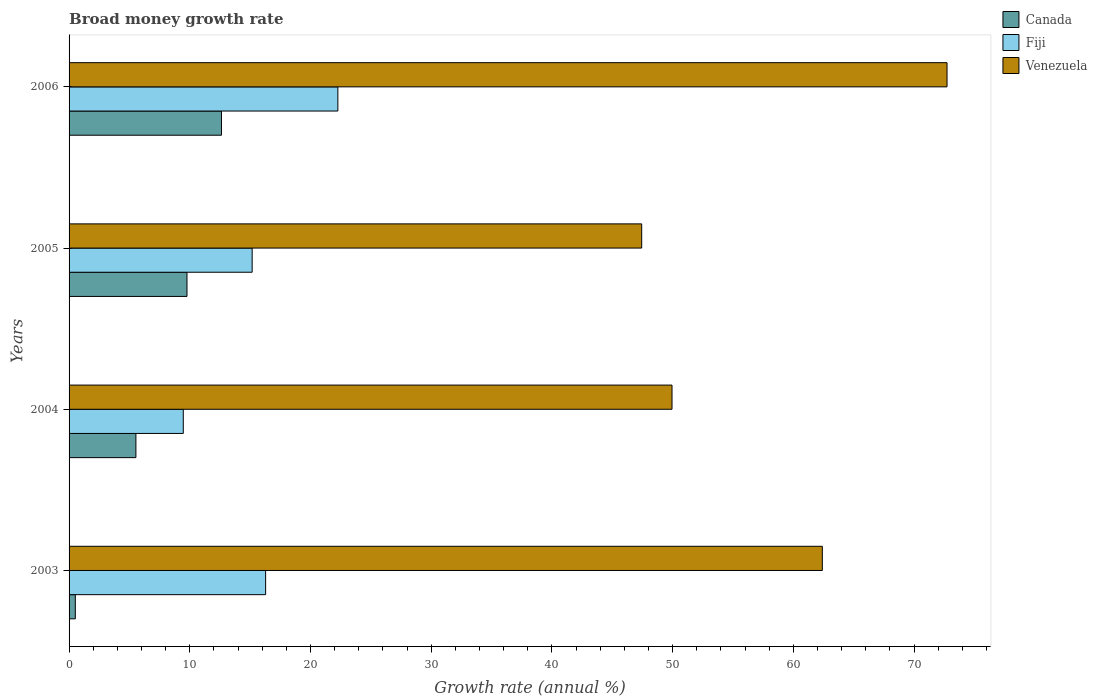How many different coloured bars are there?
Provide a short and direct response. 3. Are the number of bars per tick equal to the number of legend labels?
Your answer should be very brief. Yes. Are the number of bars on each tick of the Y-axis equal?
Ensure brevity in your answer.  Yes. How many bars are there on the 2nd tick from the bottom?
Make the answer very short. 3. What is the label of the 2nd group of bars from the top?
Your answer should be very brief. 2005. In how many cases, is the number of bars for a given year not equal to the number of legend labels?
Your answer should be very brief. 0. What is the growth rate in Canada in 2006?
Make the answer very short. 12.63. Across all years, what is the maximum growth rate in Fiji?
Your answer should be very brief. 22.27. Across all years, what is the minimum growth rate in Venezuela?
Keep it short and to the point. 47.44. In which year was the growth rate in Venezuela minimum?
Your response must be concise. 2005. What is the total growth rate in Fiji in the graph?
Your answer should be compact. 63.18. What is the difference between the growth rate in Canada in 2003 and that in 2005?
Provide a succinct answer. -9.25. What is the difference between the growth rate in Venezuela in 2004 and the growth rate in Fiji in 2003?
Your answer should be compact. 33.67. What is the average growth rate in Fiji per year?
Your answer should be compact. 15.8. In the year 2003, what is the difference between the growth rate in Venezuela and growth rate in Fiji?
Offer a terse response. 46.12. What is the ratio of the growth rate in Fiji in 2003 to that in 2005?
Keep it short and to the point. 1.07. Is the difference between the growth rate in Venezuela in 2003 and 2006 greater than the difference between the growth rate in Fiji in 2003 and 2006?
Provide a succinct answer. No. What is the difference between the highest and the second highest growth rate in Fiji?
Ensure brevity in your answer.  5.98. What is the difference between the highest and the lowest growth rate in Canada?
Your response must be concise. 12.11. In how many years, is the growth rate in Venezuela greater than the average growth rate in Venezuela taken over all years?
Your answer should be compact. 2. What does the 2nd bar from the top in 2003 represents?
Provide a short and direct response. Fiji. What does the 1st bar from the bottom in 2005 represents?
Offer a very short reply. Canada. Is it the case that in every year, the sum of the growth rate in Venezuela and growth rate in Fiji is greater than the growth rate in Canada?
Your answer should be compact. Yes. Are all the bars in the graph horizontal?
Ensure brevity in your answer.  Yes. Are the values on the major ticks of X-axis written in scientific E-notation?
Your answer should be compact. No. Does the graph contain grids?
Your response must be concise. No. How many legend labels are there?
Make the answer very short. 3. How are the legend labels stacked?
Keep it short and to the point. Vertical. What is the title of the graph?
Your response must be concise. Broad money growth rate. Does "Qatar" appear as one of the legend labels in the graph?
Keep it short and to the point. No. What is the label or title of the X-axis?
Give a very brief answer. Growth rate (annual %). What is the label or title of the Y-axis?
Offer a very short reply. Years. What is the Growth rate (annual %) of Canada in 2003?
Provide a succinct answer. 0.52. What is the Growth rate (annual %) of Fiji in 2003?
Your answer should be very brief. 16.28. What is the Growth rate (annual %) in Venezuela in 2003?
Offer a very short reply. 62.41. What is the Growth rate (annual %) in Canada in 2004?
Your response must be concise. 5.54. What is the Growth rate (annual %) of Fiji in 2004?
Provide a succinct answer. 9.46. What is the Growth rate (annual %) in Venezuela in 2004?
Your response must be concise. 49.95. What is the Growth rate (annual %) in Canada in 2005?
Provide a succinct answer. 9.77. What is the Growth rate (annual %) of Fiji in 2005?
Your answer should be very brief. 15.17. What is the Growth rate (annual %) in Venezuela in 2005?
Your answer should be compact. 47.44. What is the Growth rate (annual %) in Canada in 2006?
Provide a succinct answer. 12.63. What is the Growth rate (annual %) of Fiji in 2006?
Offer a very short reply. 22.27. What is the Growth rate (annual %) in Venezuela in 2006?
Your response must be concise. 72.74. Across all years, what is the maximum Growth rate (annual %) in Canada?
Your answer should be compact. 12.63. Across all years, what is the maximum Growth rate (annual %) in Fiji?
Offer a very short reply. 22.27. Across all years, what is the maximum Growth rate (annual %) in Venezuela?
Keep it short and to the point. 72.74. Across all years, what is the minimum Growth rate (annual %) in Canada?
Offer a very short reply. 0.52. Across all years, what is the minimum Growth rate (annual %) of Fiji?
Your response must be concise. 9.46. Across all years, what is the minimum Growth rate (annual %) in Venezuela?
Keep it short and to the point. 47.44. What is the total Growth rate (annual %) in Canada in the graph?
Give a very brief answer. 28.45. What is the total Growth rate (annual %) in Fiji in the graph?
Your answer should be compact. 63.18. What is the total Growth rate (annual %) of Venezuela in the graph?
Your response must be concise. 232.53. What is the difference between the Growth rate (annual %) of Canada in 2003 and that in 2004?
Offer a terse response. -5.02. What is the difference between the Growth rate (annual %) in Fiji in 2003 and that in 2004?
Make the answer very short. 6.82. What is the difference between the Growth rate (annual %) of Venezuela in 2003 and that in 2004?
Ensure brevity in your answer.  12.45. What is the difference between the Growth rate (annual %) in Canada in 2003 and that in 2005?
Offer a very short reply. -9.25. What is the difference between the Growth rate (annual %) of Fiji in 2003 and that in 2005?
Give a very brief answer. 1.12. What is the difference between the Growth rate (annual %) of Venezuela in 2003 and that in 2005?
Offer a very short reply. 14.97. What is the difference between the Growth rate (annual %) in Canada in 2003 and that in 2006?
Provide a succinct answer. -12.11. What is the difference between the Growth rate (annual %) in Fiji in 2003 and that in 2006?
Your answer should be compact. -5.98. What is the difference between the Growth rate (annual %) in Venezuela in 2003 and that in 2006?
Provide a succinct answer. -10.33. What is the difference between the Growth rate (annual %) in Canada in 2004 and that in 2005?
Provide a short and direct response. -4.23. What is the difference between the Growth rate (annual %) of Fiji in 2004 and that in 2005?
Keep it short and to the point. -5.71. What is the difference between the Growth rate (annual %) of Venezuela in 2004 and that in 2005?
Your answer should be very brief. 2.51. What is the difference between the Growth rate (annual %) in Canada in 2004 and that in 2006?
Your answer should be very brief. -7.09. What is the difference between the Growth rate (annual %) of Fiji in 2004 and that in 2006?
Ensure brevity in your answer.  -12.81. What is the difference between the Growth rate (annual %) in Venezuela in 2004 and that in 2006?
Make the answer very short. -22.78. What is the difference between the Growth rate (annual %) of Canada in 2005 and that in 2006?
Offer a terse response. -2.86. What is the difference between the Growth rate (annual %) of Venezuela in 2005 and that in 2006?
Offer a very short reply. -25.3. What is the difference between the Growth rate (annual %) in Canada in 2003 and the Growth rate (annual %) in Fiji in 2004?
Give a very brief answer. -8.94. What is the difference between the Growth rate (annual %) of Canada in 2003 and the Growth rate (annual %) of Venezuela in 2004?
Your answer should be compact. -49.43. What is the difference between the Growth rate (annual %) of Fiji in 2003 and the Growth rate (annual %) of Venezuela in 2004?
Ensure brevity in your answer.  -33.67. What is the difference between the Growth rate (annual %) in Canada in 2003 and the Growth rate (annual %) in Fiji in 2005?
Give a very brief answer. -14.65. What is the difference between the Growth rate (annual %) of Canada in 2003 and the Growth rate (annual %) of Venezuela in 2005?
Keep it short and to the point. -46.92. What is the difference between the Growth rate (annual %) in Fiji in 2003 and the Growth rate (annual %) in Venezuela in 2005?
Provide a succinct answer. -31.16. What is the difference between the Growth rate (annual %) in Canada in 2003 and the Growth rate (annual %) in Fiji in 2006?
Keep it short and to the point. -21.75. What is the difference between the Growth rate (annual %) of Canada in 2003 and the Growth rate (annual %) of Venezuela in 2006?
Your answer should be very brief. -72.22. What is the difference between the Growth rate (annual %) of Fiji in 2003 and the Growth rate (annual %) of Venezuela in 2006?
Offer a terse response. -56.45. What is the difference between the Growth rate (annual %) of Canada in 2004 and the Growth rate (annual %) of Fiji in 2005?
Give a very brief answer. -9.63. What is the difference between the Growth rate (annual %) in Canada in 2004 and the Growth rate (annual %) in Venezuela in 2005?
Offer a terse response. -41.9. What is the difference between the Growth rate (annual %) of Fiji in 2004 and the Growth rate (annual %) of Venezuela in 2005?
Provide a short and direct response. -37.98. What is the difference between the Growth rate (annual %) of Canada in 2004 and the Growth rate (annual %) of Fiji in 2006?
Your response must be concise. -16.73. What is the difference between the Growth rate (annual %) in Canada in 2004 and the Growth rate (annual %) in Venezuela in 2006?
Offer a very short reply. -67.2. What is the difference between the Growth rate (annual %) in Fiji in 2004 and the Growth rate (annual %) in Venezuela in 2006?
Provide a succinct answer. -63.27. What is the difference between the Growth rate (annual %) in Canada in 2005 and the Growth rate (annual %) in Fiji in 2006?
Offer a terse response. -12.5. What is the difference between the Growth rate (annual %) of Canada in 2005 and the Growth rate (annual %) of Venezuela in 2006?
Make the answer very short. -62.97. What is the difference between the Growth rate (annual %) of Fiji in 2005 and the Growth rate (annual %) of Venezuela in 2006?
Keep it short and to the point. -57.57. What is the average Growth rate (annual %) of Canada per year?
Give a very brief answer. 7.11. What is the average Growth rate (annual %) of Fiji per year?
Provide a succinct answer. 15.8. What is the average Growth rate (annual %) of Venezuela per year?
Provide a short and direct response. 58.13. In the year 2003, what is the difference between the Growth rate (annual %) of Canada and Growth rate (annual %) of Fiji?
Provide a short and direct response. -15.77. In the year 2003, what is the difference between the Growth rate (annual %) of Canada and Growth rate (annual %) of Venezuela?
Keep it short and to the point. -61.89. In the year 2003, what is the difference between the Growth rate (annual %) in Fiji and Growth rate (annual %) in Venezuela?
Your answer should be compact. -46.12. In the year 2004, what is the difference between the Growth rate (annual %) of Canada and Growth rate (annual %) of Fiji?
Offer a terse response. -3.93. In the year 2004, what is the difference between the Growth rate (annual %) in Canada and Growth rate (annual %) in Venezuela?
Your answer should be compact. -44.41. In the year 2004, what is the difference between the Growth rate (annual %) of Fiji and Growth rate (annual %) of Venezuela?
Your answer should be very brief. -40.49. In the year 2005, what is the difference between the Growth rate (annual %) of Canada and Growth rate (annual %) of Fiji?
Provide a succinct answer. -5.4. In the year 2005, what is the difference between the Growth rate (annual %) of Canada and Growth rate (annual %) of Venezuela?
Your answer should be compact. -37.67. In the year 2005, what is the difference between the Growth rate (annual %) in Fiji and Growth rate (annual %) in Venezuela?
Ensure brevity in your answer.  -32.27. In the year 2006, what is the difference between the Growth rate (annual %) in Canada and Growth rate (annual %) in Fiji?
Keep it short and to the point. -9.64. In the year 2006, what is the difference between the Growth rate (annual %) in Canada and Growth rate (annual %) in Venezuela?
Your answer should be very brief. -60.11. In the year 2006, what is the difference between the Growth rate (annual %) in Fiji and Growth rate (annual %) in Venezuela?
Provide a short and direct response. -50.47. What is the ratio of the Growth rate (annual %) in Canada in 2003 to that in 2004?
Your answer should be compact. 0.09. What is the ratio of the Growth rate (annual %) of Fiji in 2003 to that in 2004?
Your answer should be compact. 1.72. What is the ratio of the Growth rate (annual %) in Venezuela in 2003 to that in 2004?
Make the answer very short. 1.25. What is the ratio of the Growth rate (annual %) of Canada in 2003 to that in 2005?
Provide a short and direct response. 0.05. What is the ratio of the Growth rate (annual %) of Fiji in 2003 to that in 2005?
Give a very brief answer. 1.07. What is the ratio of the Growth rate (annual %) of Venezuela in 2003 to that in 2005?
Ensure brevity in your answer.  1.32. What is the ratio of the Growth rate (annual %) of Canada in 2003 to that in 2006?
Your answer should be very brief. 0.04. What is the ratio of the Growth rate (annual %) of Fiji in 2003 to that in 2006?
Give a very brief answer. 0.73. What is the ratio of the Growth rate (annual %) in Venezuela in 2003 to that in 2006?
Provide a short and direct response. 0.86. What is the ratio of the Growth rate (annual %) of Canada in 2004 to that in 2005?
Keep it short and to the point. 0.57. What is the ratio of the Growth rate (annual %) of Fiji in 2004 to that in 2005?
Ensure brevity in your answer.  0.62. What is the ratio of the Growth rate (annual %) of Venezuela in 2004 to that in 2005?
Give a very brief answer. 1.05. What is the ratio of the Growth rate (annual %) of Canada in 2004 to that in 2006?
Offer a very short reply. 0.44. What is the ratio of the Growth rate (annual %) in Fiji in 2004 to that in 2006?
Your answer should be compact. 0.42. What is the ratio of the Growth rate (annual %) in Venezuela in 2004 to that in 2006?
Offer a terse response. 0.69. What is the ratio of the Growth rate (annual %) in Canada in 2005 to that in 2006?
Your answer should be very brief. 0.77. What is the ratio of the Growth rate (annual %) in Fiji in 2005 to that in 2006?
Make the answer very short. 0.68. What is the ratio of the Growth rate (annual %) of Venezuela in 2005 to that in 2006?
Provide a short and direct response. 0.65. What is the difference between the highest and the second highest Growth rate (annual %) of Canada?
Your response must be concise. 2.86. What is the difference between the highest and the second highest Growth rate (annual %) of Fiji?
Your answer should be very brief. 5.98. What is the difference between the highest and the second highest Growth rate (annual %) in Venezuela?
Give a very brief answer. 10.33. What is the difference between the highest and the lowest Growth rate (annual %) in Canada?
Your answer should be very brief. 12.11. What is the difference between the highest and the lowest Growth rate (annual %) in Fiji?
Your response must be concise. 12.81. What is the difference between the highest and the lowest Growth rate (annual %) in Venezuela?
Provide a short and direct response. 25.3. 